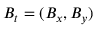Convert formula to latex. <formula><loc_0><loc_0><loc_500><loc_500>B _ { t } = ( B _ { x } , B _ { y } )</formula> 